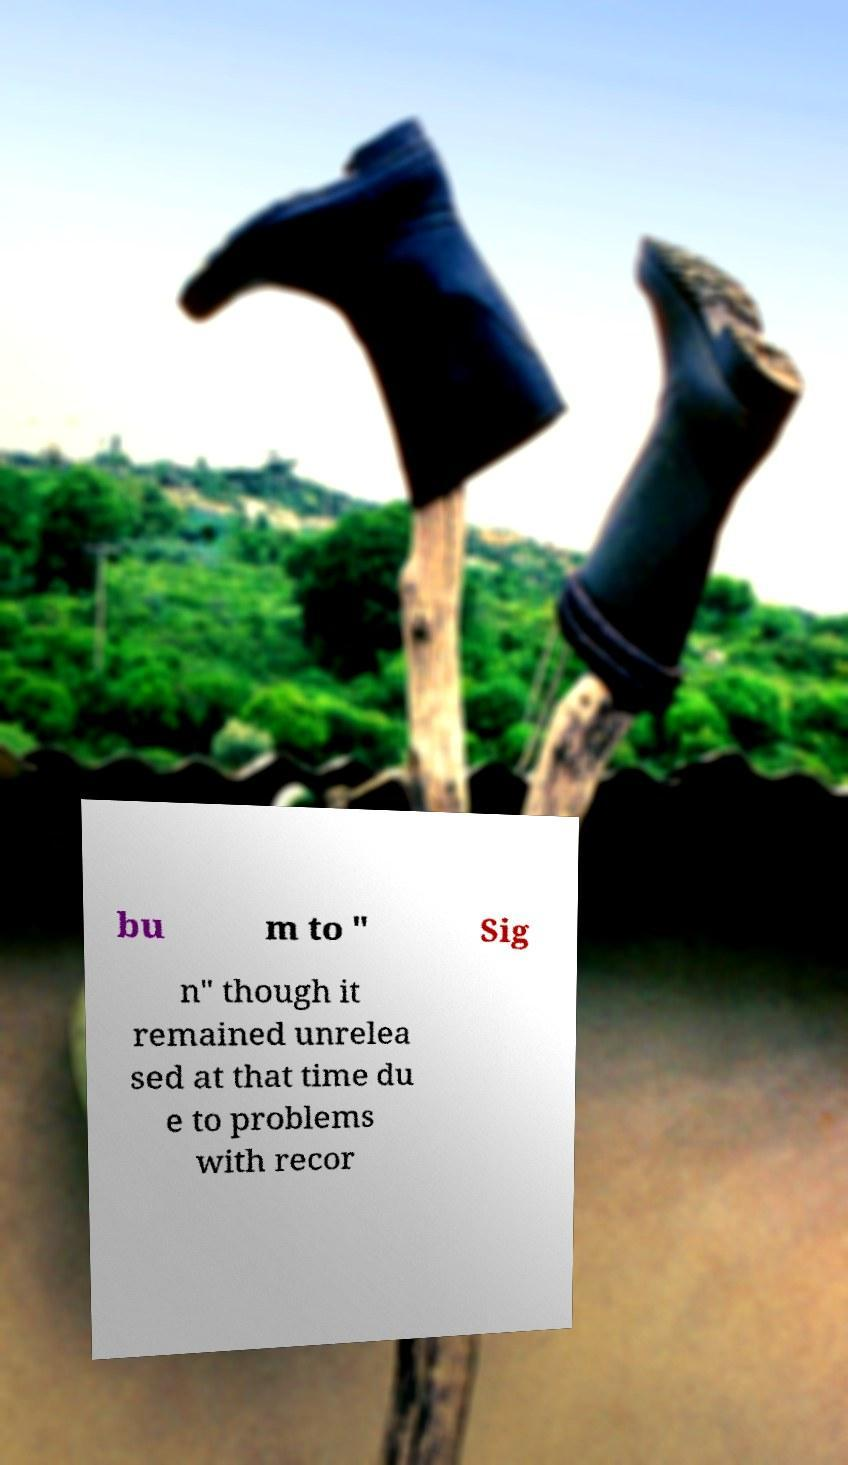Please identify and transcribe the text found in this image. bu m to " Sig n" though it remained unrelea sed at that time du e to problems with recor 